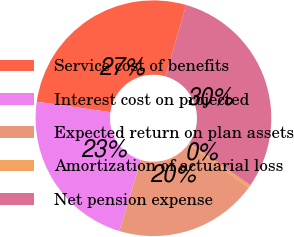Convert chart to OTSL. <chart><loc_0><loc_0><loc_500><loc_500><pie_chart><fcel>Service cost of benefits<fcel>Interest cost on projected<fcel>Expected return on plan assets<fcel>Amortization of actuarial loss<fcel>Net pension expense<nl><fcel>27.24%<fcel>22.56%<fcel>19.65%<fcel>0.41%<fcel>30.15%<nl></chart> 